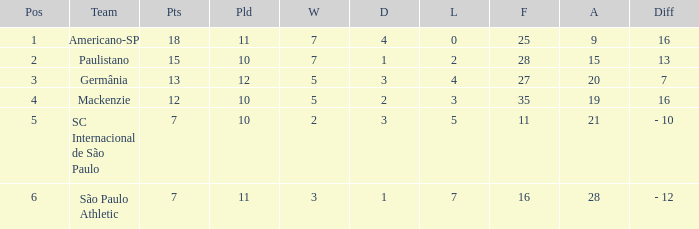Name the points for paulistano 15.0. 